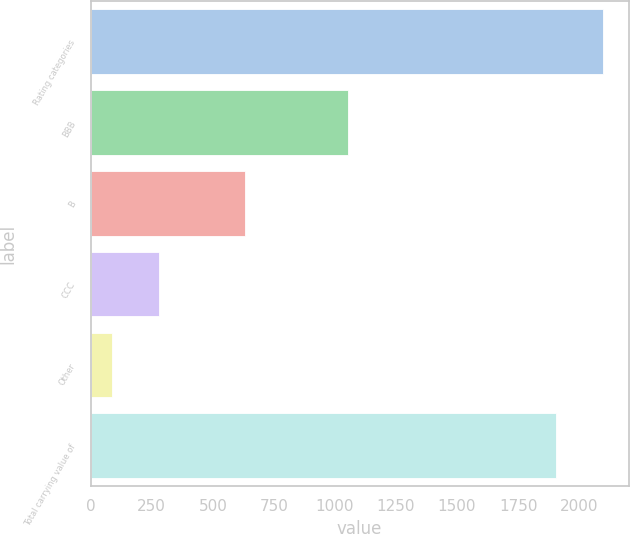<chart> <loc_0><loc_0><loc_500><loc_500><bar_chart><fcel>Rating categories<fcel>BBB<fcel>B<fcel>CCC<fcel>Other<fcel>Total carrying value of<nl><fcel>2097.8<fcel>1055<fcel>633<fcel>278.8<fcel>86<fcel>1905<nl></chart> 